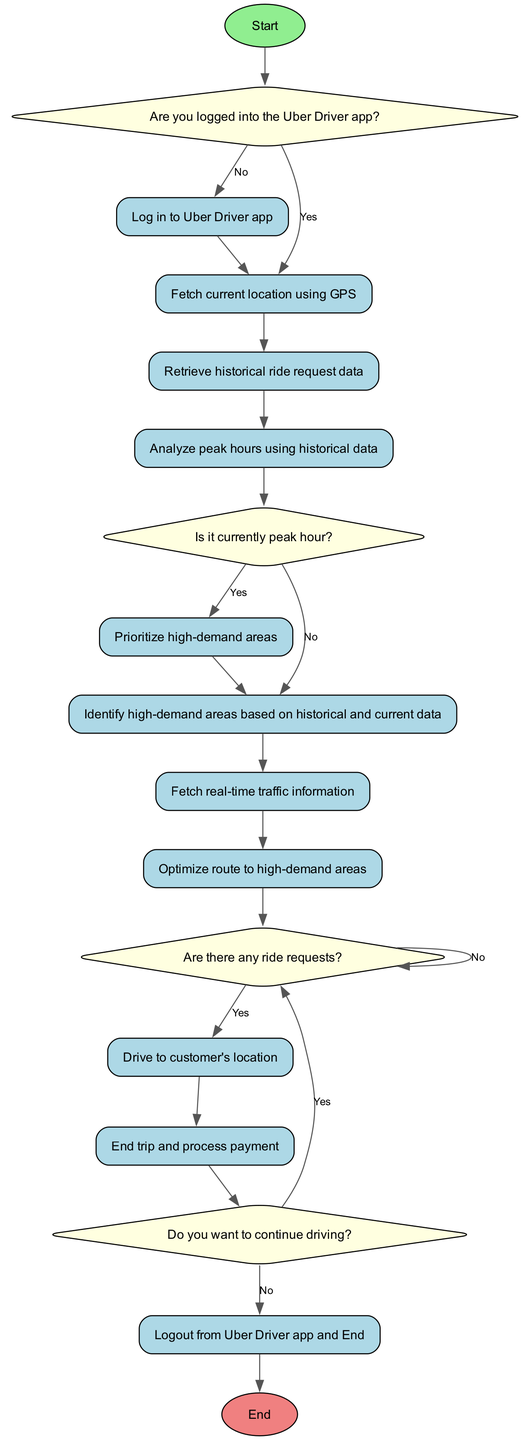What is the first step in the flowchart? The first step in the flowchart is labeled "Start," indicating the beginning of the optimization process for the Uber driver.
Answer: Start What happens if you are not logged into the Uber Driver app? If you are not logged in, the flowchart directs you to "Log in to Uber Driver app" as the next step before proceeding.
Answer: Log in to Uber Driver app What node comes after checking the current time? After checking the current time, the next node becomes "Identify high-demand areas based on historical and current data."
Answer: Identify high-demand areas based on historical and current data Are there any conditions under which a rider is accepted? Yes, the flowchart specifies that if there are ride requests, the action taken is to "Accept ride request."
Answer: Accept ride request What action is taken if the current time is a peak hour? If the current time is a peak hour, the flowchart indicates that you should "Prioritize high-demand areas."
Answer: Prioritize high-demand areas How many times can the driver check for ride requests after completing a trip? The diagram allows the driver to check for ride requests continuously without a limit; there is an arrow that loops back to the "check for ride requests" node.
Answer: Continuous What is required before optimizing the route? Before optimizing the route, it is necessary to fetch real-time traffic information, as indicated by the sequence leading up to the "Optimize route" node.
Answer: Fetch real-time traffic information What are the consequences of choosing "No" to wanting to continue driving? If the driver chooses "No" to continue driving, the flowchart directs to "Logout from Uber Driver app and End."
Answer: Logout from Uber Driver app and End What does the diagram indicate about the conditions for driving to the customer? The diagram shows that driving to the customer occurs only if the check for ride requests is "Yes," meaning that a ride request has been accepted.
Answer: Drive to customer's location 